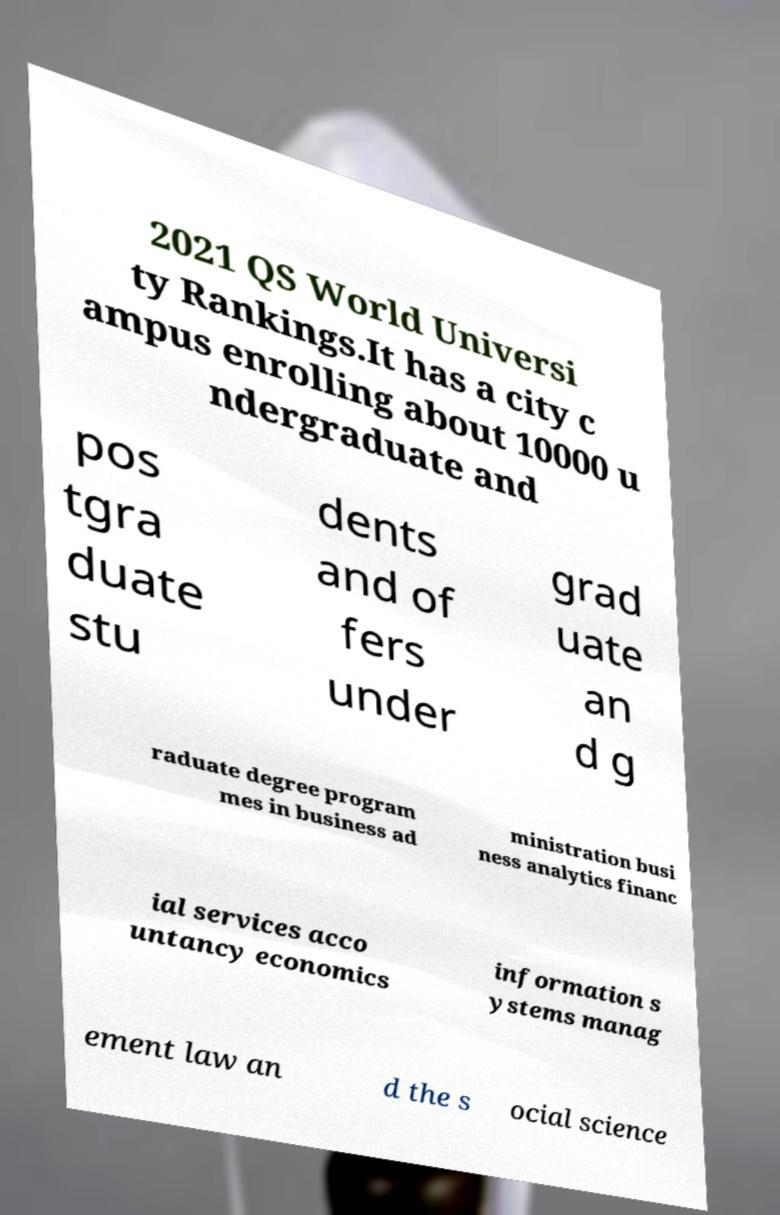There's text embedded in this image that I need extracted. Can you transcribe it verbatim? 2021 QS World Universi ty Rankings.It has a city c ampus enrolling about 10000 u ndergraduate and pos tgra duate stu dents and of fers under grad uate an d g raduate degree program mes in business ad ministration busi ness analytics financ ial services acco untancy economics information s ystems manag ement law an d the s ocial science 